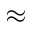Convert formula to latex. <formula><loc_0><loc_0><loc_500><loc_500>\approx</formula> 